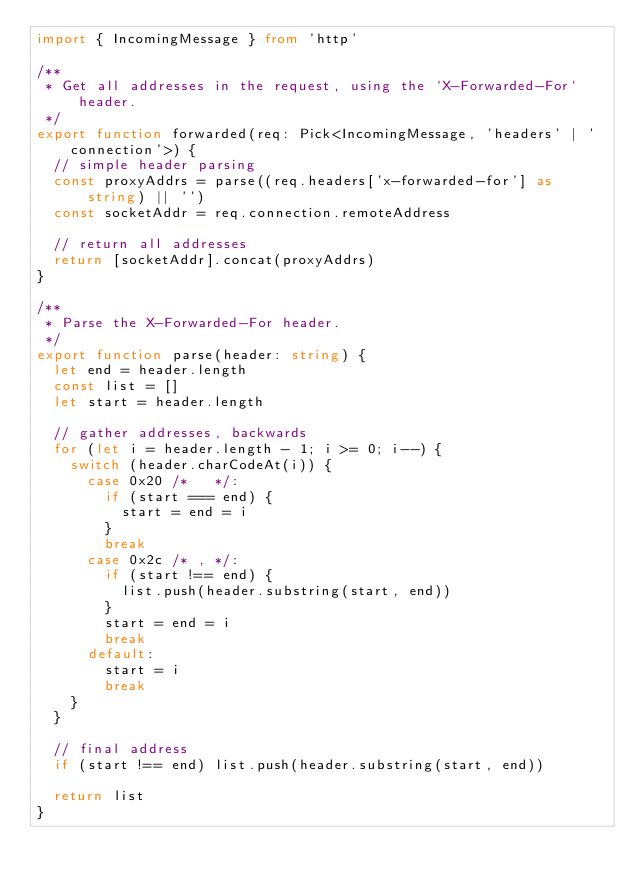Convert code to text. <code><loc_0><loc_0><loc_500><loc_500><_TypeScript_>import { IncomingMessage } from 'http'

/**
 * Get all addresses in the request, using the `X-Forwarded-For` header.
 */
export function forwarded(req: Pick<IncomingMessage, 'headers' | 'connection'>) {
  // simple header parsing
  const proxyAddrs = parse((req.headers['x-forwarded-for'] as string) || '')
  const socketAddr = req.connection.remoteAddress

  // return all addresses
  return [socketAddr].concat(proxyAddrs)
}

/**
 * Parse the X-Forwarded-For header.
 */
export function parse(header: string) {
  let end = header.length
  const list = []
  let start = header.length

  // gather addresses, backwards
  for (let i = header.length - 1; i >= 0; i--) {
    switch (header.charCodeAt(i)) {
      case 0x20 /*   */:
        if (start === end) {
          start = end = i
        }
        break
      case 0x2c /* , */:
        if (start !== end) {
          list.push(header.substring(start, end))
        }
        start = end = i
        break
      default:
        start = i
        break
    }
  }

  // final address
  if (start !== end) list.push(header.substring(start, end))

  return list
}
</code> 